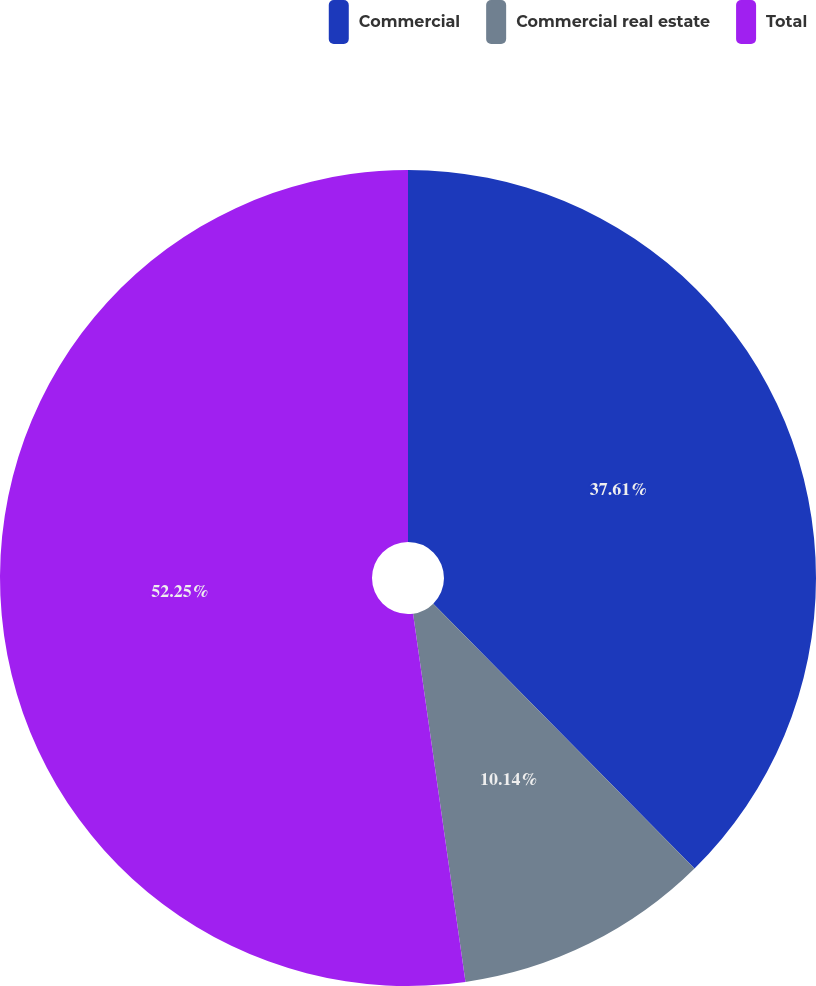Convert chart to OTSL. <chart><loc_0><loc_0><loc_500><loc_500><pie_chart><fcel>Commercial<fcel>Commercial real estate<fcel>Total<nl><fcel>37.61%<fcel>10.14%<fcel>52.25%<nl></chart> 